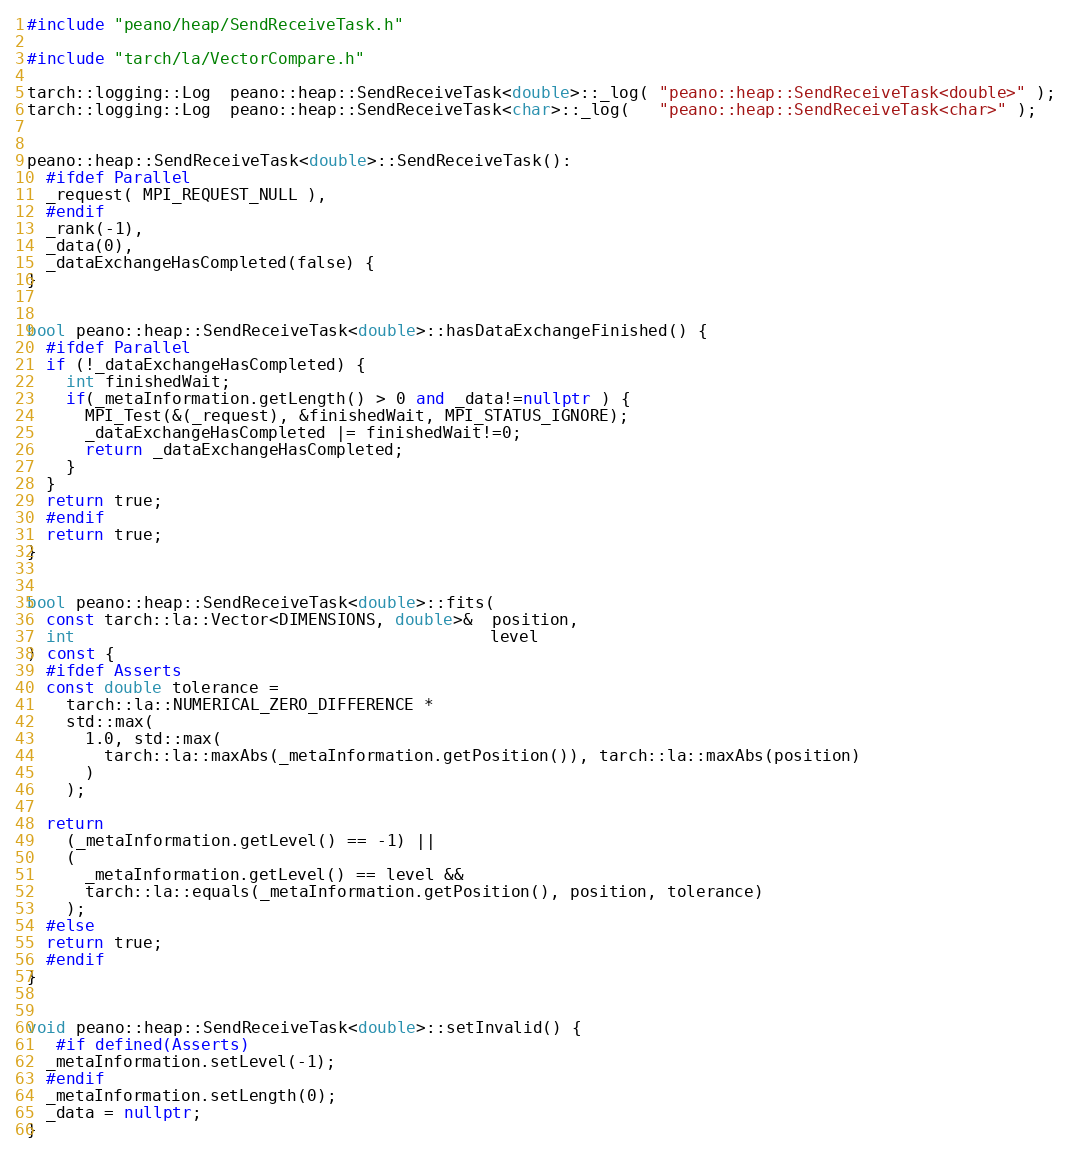Convert code to text. <code><loc_0><loc_0><loc_500><loc_500><_C++_>#include "peano/heap/SendReceiveTask.h"

#include "tarch/la/VectorCompare.h"

tarch::logging::Log  peano::heap::SendReceiveTask<double>::_log( "peano::heap::SendReceiveTask<double>" );
tarch::logging::Log  peano::heap::SendReceiveTask<char>::_log(   "peano::heap::SendReceiveTask<char>" );


peano::heap::SendReceiveTask<double>::SendReceiveTask():
  #ifdef Parallel
  _request( MPI_REQUEST_NULL ),
  #endif
  _rank(-1),
  _data(0),
  _dataExchangeHasCompleted(false) {
}


bool peano::heap::SendReceiveTask<double>::hasDataExchangeFinished() {
  #ifdef Parallel
  if (!_dataExchangeHasCompleted) {
    int finishedWait;
    if(_metaInformation.getLength() > 0 and _data!=nullptr ) {
      MPI_Test(&(_request), &finishedWait, MPI_STATUS_IGNORE);
      _dataExchangeHasCompleted |= finishedWait!=0;
      return _dataExchangeHasCompleted;
    }
  }
  return true;
  #endif
  return true;
}


bool peano::heap::SendReceiveTask<double>::fits(
  const tarch::la::Vector<DIMENSIONS, double>&  position,
  int                                           level
) const {
  #ifdef Asserts
  const double tolerance =
    tarch::la::NUMERICAL_ZERO_DIFFERENCE *
    std::max(
      1.0, std::max(
        tarch::la::maxAbs(_metaInformation.getPosition()), tarch::la::maxAbs(position)
      )
    );

  return
    (_metaInformation.getLevel() == -1) ||
    (
      _metaInformation.getLevel() == level &&
      tarch::la::equals(_metaInformation.getPosition(), position, tolerance)
    );
  #else
  return true;
  #endif
}


void peano::heap::SendReceiveTask<double>::setInvalid() {
   #if defined(Asserts)
  _metaInformation.setLevel(-1);
  #endif
  _metaInformation.setLength(0);
  _data = nullptr;
}

</code> 